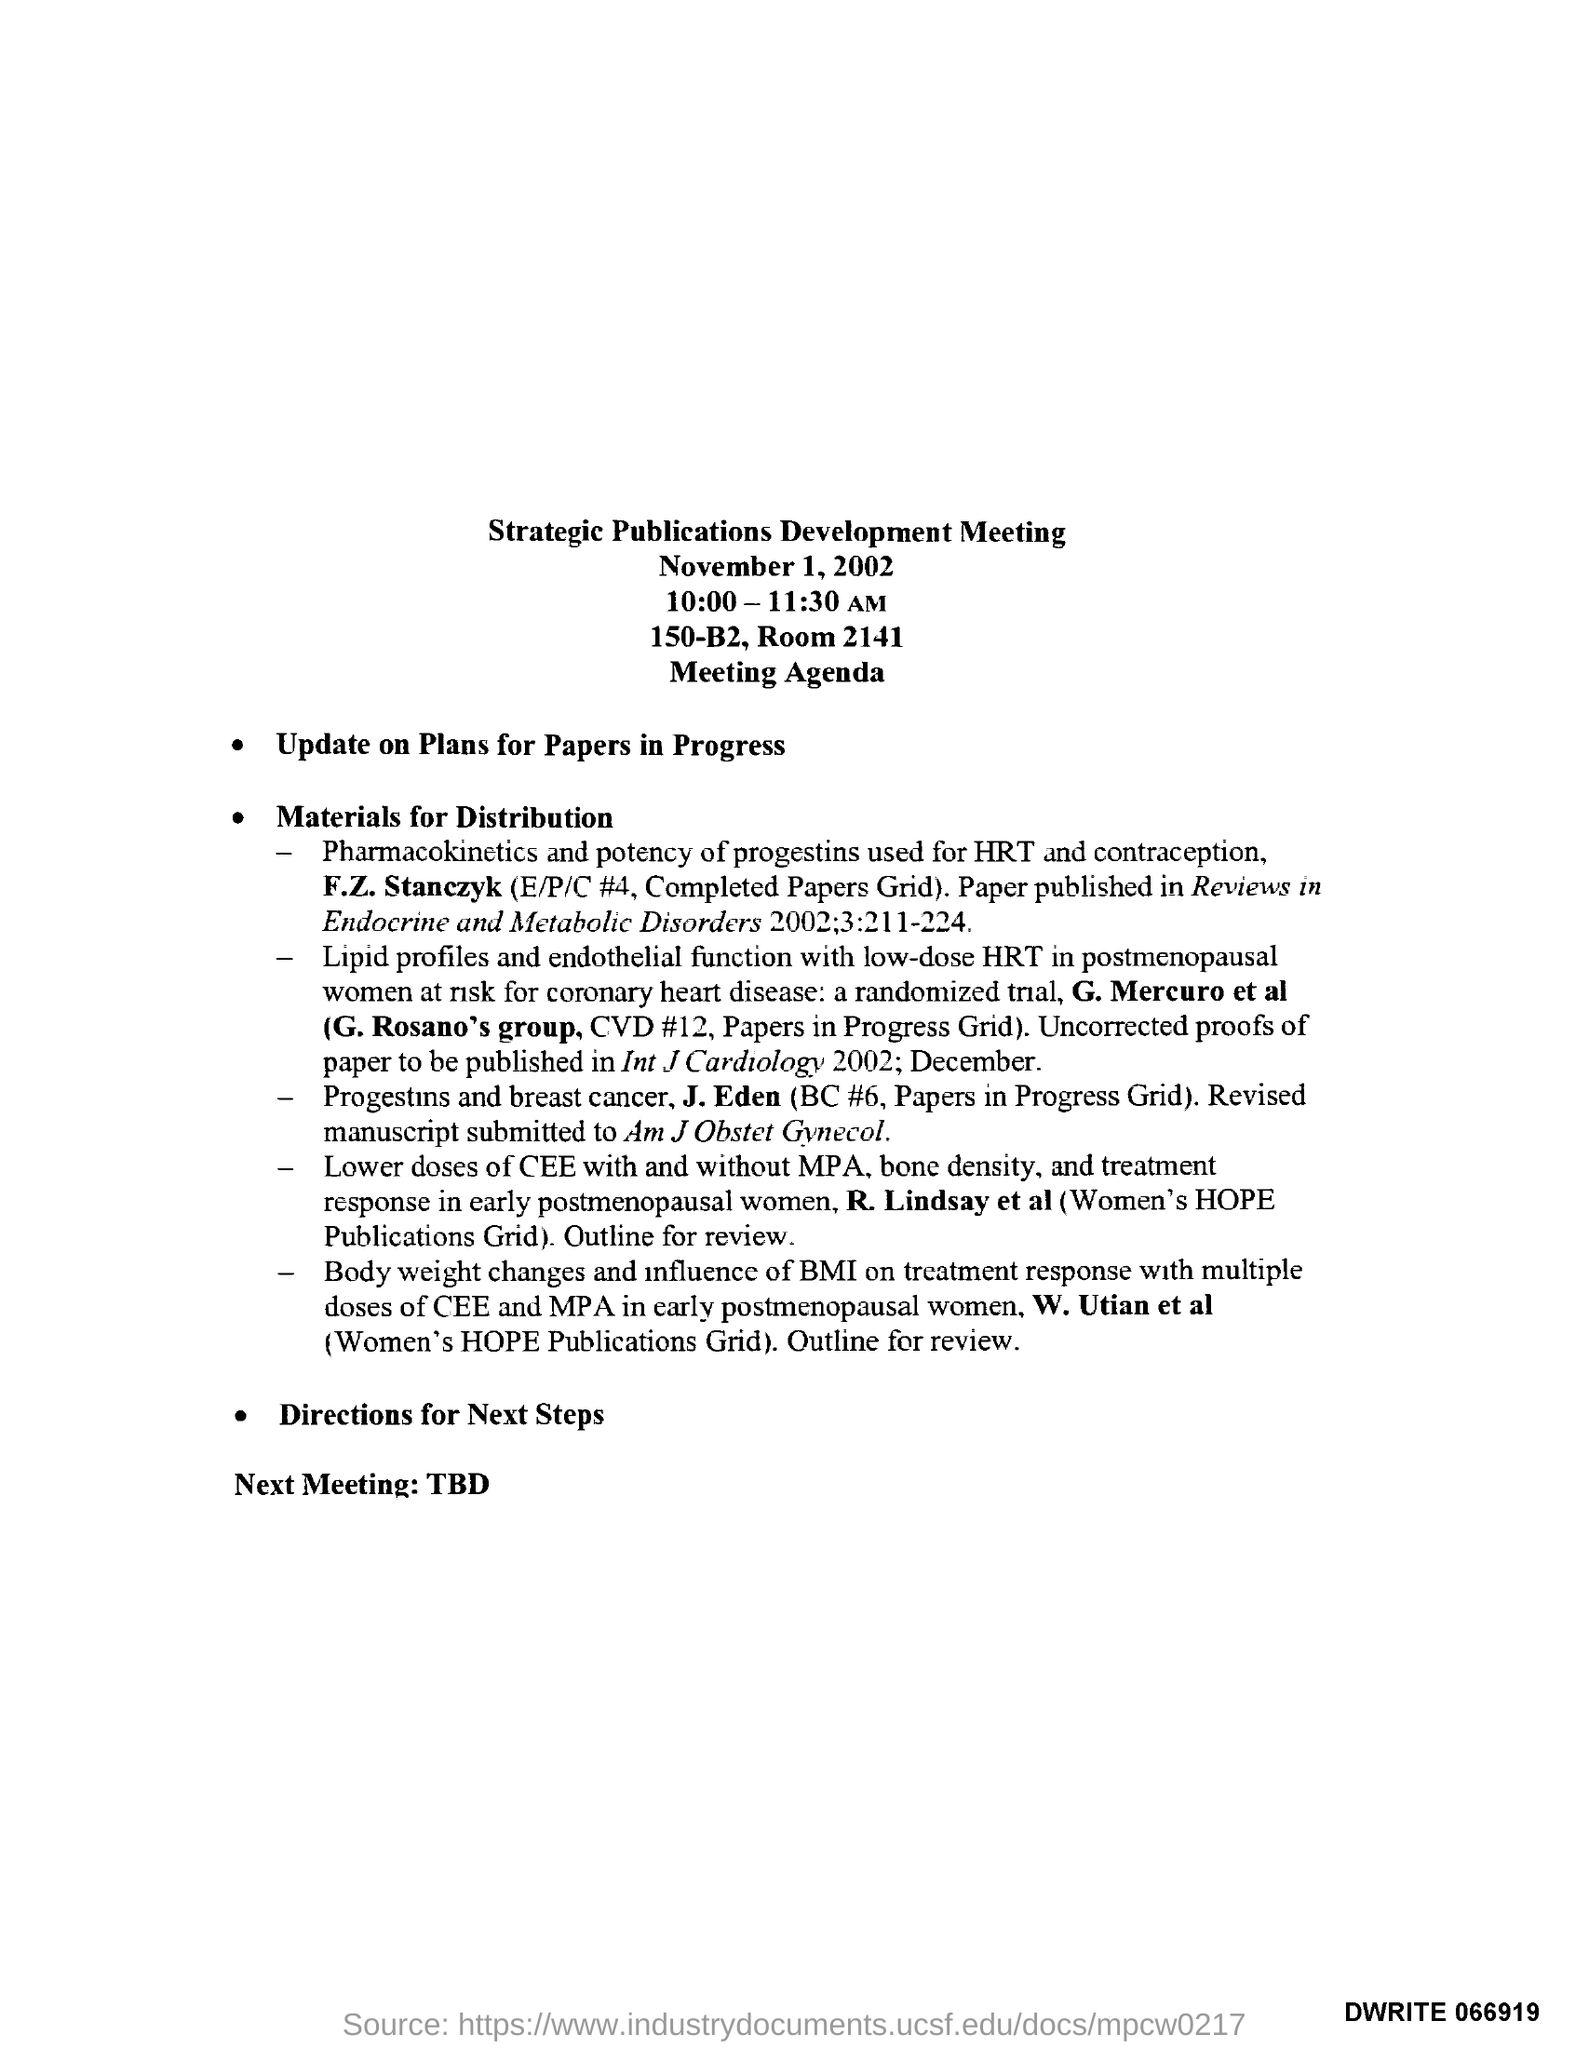What is the title of the document ?
Make the answer very short. Strategic Publications Development Meeting. What is the timing of the meeting ?
Offer a very short reply. 10:00 - 11:30 AM. 